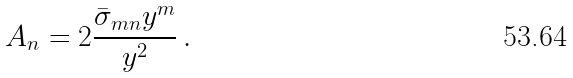Convert formula to latex. <formula><loc_0><loc_0><loc_500><loc_500>A _ { n } = 2 \frac { \bar { \sigma } _ { m n } y ^ { m } } { y ^ { 2 } } \, .</formula> 